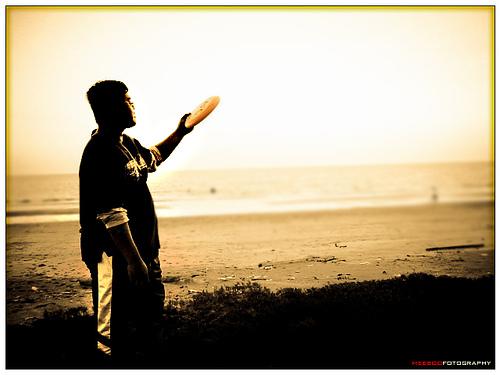What is the brightest object shown in the picture?
Write a very short answer. Frisbee. Was this picture taken on a west coast?
Keep it brief. Yes. Does this man have his eyes closed?
Answer briefly. No. 